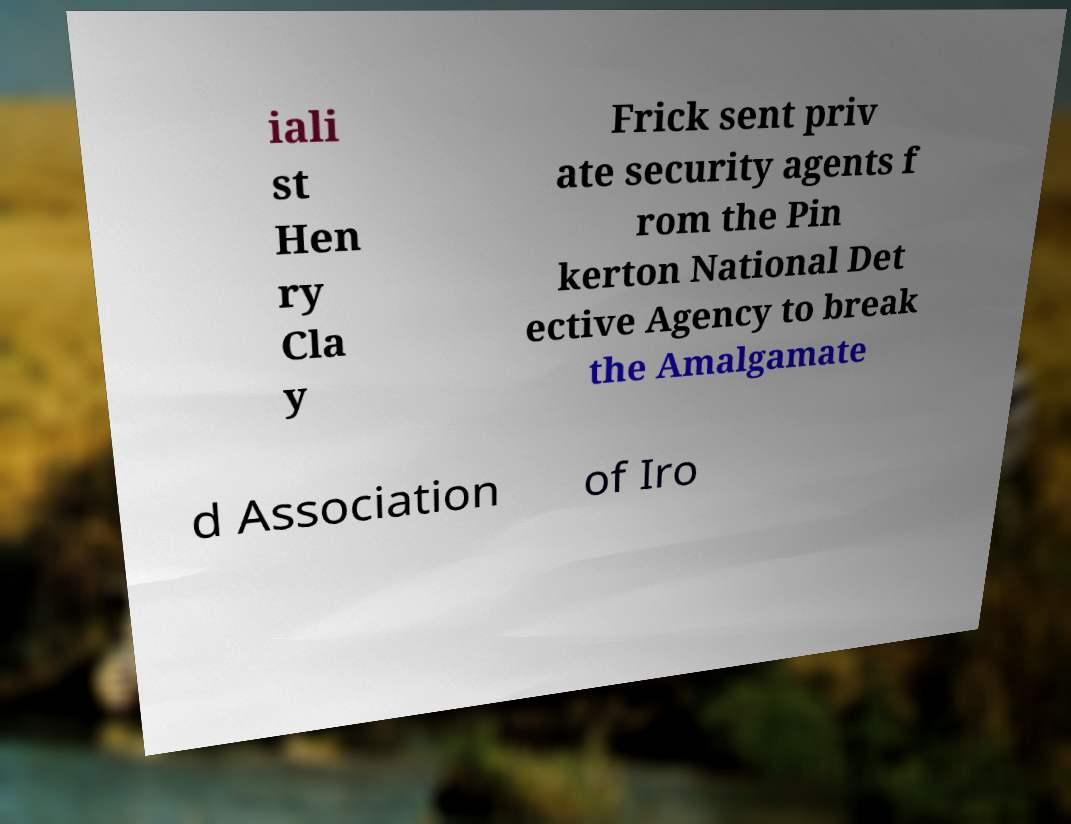Can you read and provide the text displayed in the image?This photo seems to have some interesting text. Can you extract and type it out for me? iali st Hen ry Cla y Frick sent priv ate security agents f rom the Pin kerton National Det ective Agency to break the Amalgamate d Association of Iro 